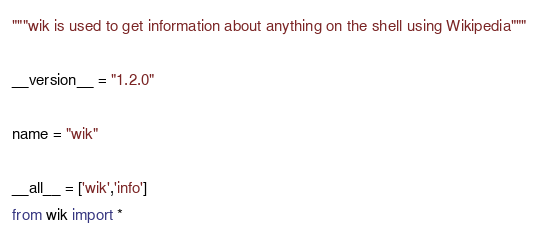Convert code to text. <code><loc_0><loc_0><loc_500><loc_500><_Python_>"""wik is used to get information about anything on the shell using Wikipedia"""

__version__ = "1.2.0"

name = "wik"

__all__ = ['wik','info']
from wik import *
</code> 